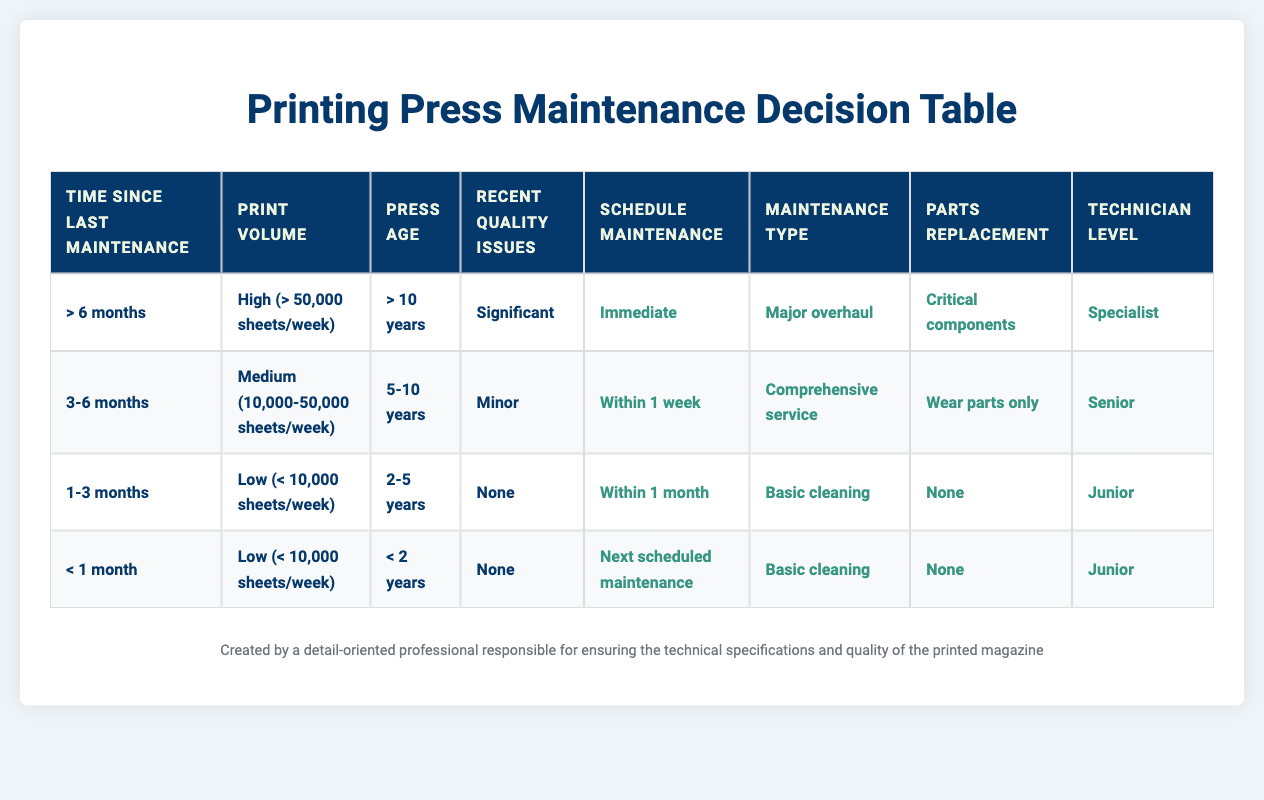What maintenance action should be taken for a press that hasn’t had maintenance for over 6 months, processes high volume, is older than 10 years, and has significant quality issues? According to the table, when the conditions are "> 6 months", "High (> 50,000 sheets/week)", "> 10 years", and "Significant", the recommended actions are to schedule maintenance "Immediate", perform a "Major overhaul", replace "Critical components", and employ a "Specialist" technician.
Answer: Immediate, Major overhaul, Critical components, Specialist What is the maintenance type recommended for a press that is 2-5 years old, has low print volume, and had no recent quality issues with a maintenance check in the last 1-3 months? The relevant row indicates the conditions are "1-3 months", "Low (< 10,000 sheets/week)", "2-5 years", and "None", leading to a recommended maintenance action of a "Basic cleaning".
Answer: Basic cleaning Is there a recommended immediate action for presses with minor quality issues? The only instance in the table of immediate action is related to significant quality issues, specifically for a situation where time since last maintenance is over 6 months. Therefore, there is no recommended immediate action for presses with minor quality issues.
Answer: No What actions are needed if a press is less than 2 years old, has low print volume, and has had no recent quality issues, with maintenance needed in less than a month? The conditions would reference the row showing "< 1 month", "Low (< 10,000 sheets/week)", "< 2 years", and "None", which indicates to schedule maintenance for "Next scheduled maintenance", perform "Basic cleaning", require "None" for parts replacement, and involve a "Junior" technician.
Answer: Next scheduled maintenance, Basic cleaning, None, Junior If the print volume is medium, how quickly should maintenance be scheduled for a 5-10 year old press with recent minor issues? According to the corresponding data, for the conditions "3-6 months", "Medium (10,000-50,000 sheets/week)", "5-10 years", and "Minor", maintenance should be scheduled "Within 1 week".
Answer: Within 1 week What is the difference in technician levels between press conditions with significant issues and those with no issues? For significant recent issues, the technician level required is "Specialist", while for cases with no issues the technician is "Junior" or "Senior." The difference is that significant cases require a higher-level technician.
Answer: Specialist, Junior/Senior (Difference: Specialist is higher) Based on the table, does a press that is less than 2 years old and has low usage typically require any parts replacement? The row for the relevant conditions shows that there would be "None" required for parts replacement.
Answer: Yes, None If a press's print volume is high, what 3 actions would be performed if it has not been maintained for over 6 months? The table provides clear actions when conditions are met, which are "Immediate" scheduling, a "Major overhaul" for maintenance type, and replacement of "Critical components."
Answer: Immediate, Major overhaul, Critical components 